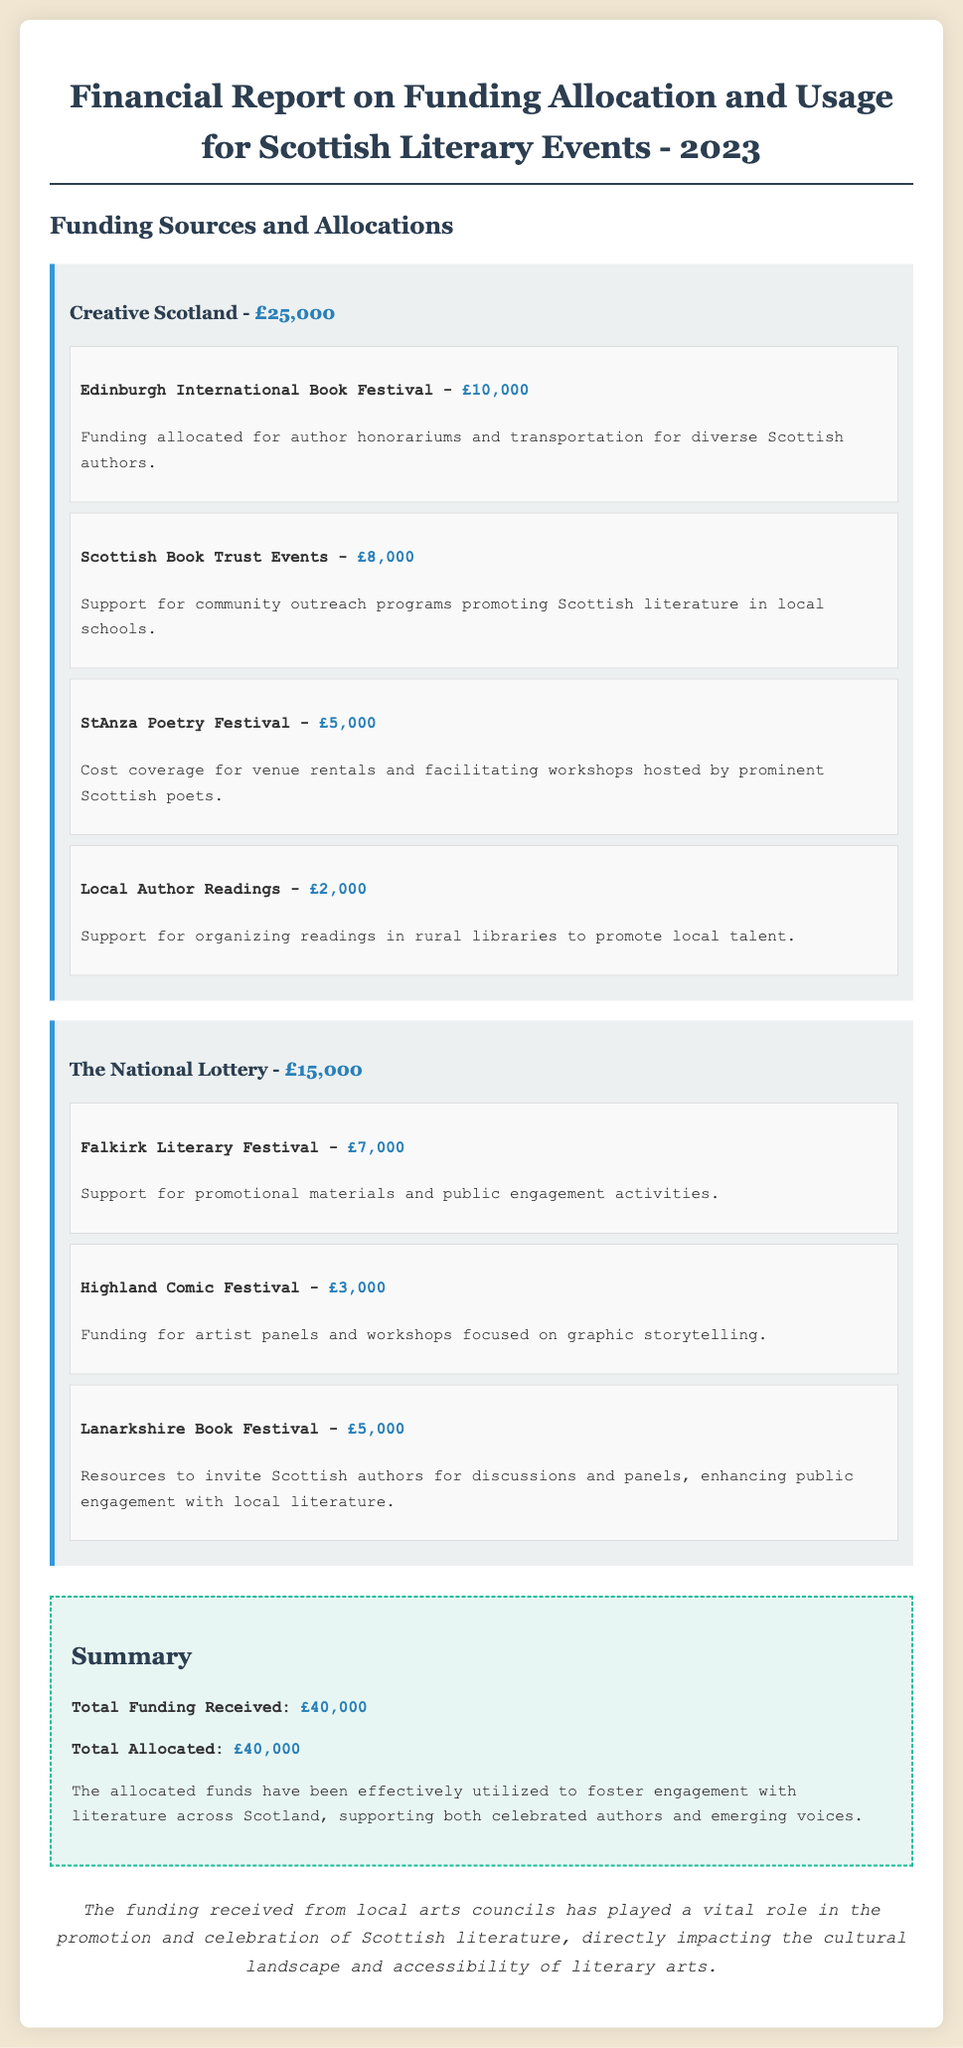What is the total funding received? The total funding received is listed in the summary section of the report.
Answer: £40,000 Who provided the funding for the Edinburgh International Book Festival? The funding source for the Edinburgh International Book Festival is specified in the funding sources section.
Answer: Creative Scotland How much was allocated to the Scottish Book Trust Events? The amount allocated to the Scottish Book Trust Events is explicitly mentioned in the report.
Answer: £8,000 What is the funding amount for the Falkirk Literary Festival? The funding amount for the Falkirk Literary Festival can be found in the section detailing allocations from The National Lottery.
Answer: £7,000 What types of activities does the funding for the Highland Comic Festival support? The report describes the purpose of the funding allocated to the Highland Comic Festival.
Answer: Artist panels and workshops Which funding source allocated more money, Creative Scotland or The National Lottery? A comparison of the amounts received from each funding source is provided in the document.
Answer: Creative Scotland What is a key outcome of the funding mentioned in the conclusion? The conclusion summarizes the impact of the funding mentioned in the report.
Answer: Promotion and celebration of Scottish literature How much total funding was used for local author readings? The total funding for local author readings is specified in the allocation details.
Answer: £2,000 What was the purpose of the allocation for StAnza Poetry Festival? The report states the reason for allocating funds to the StAnza Poetry Festival.
Answer: Venue rentals and facilitating workshops 